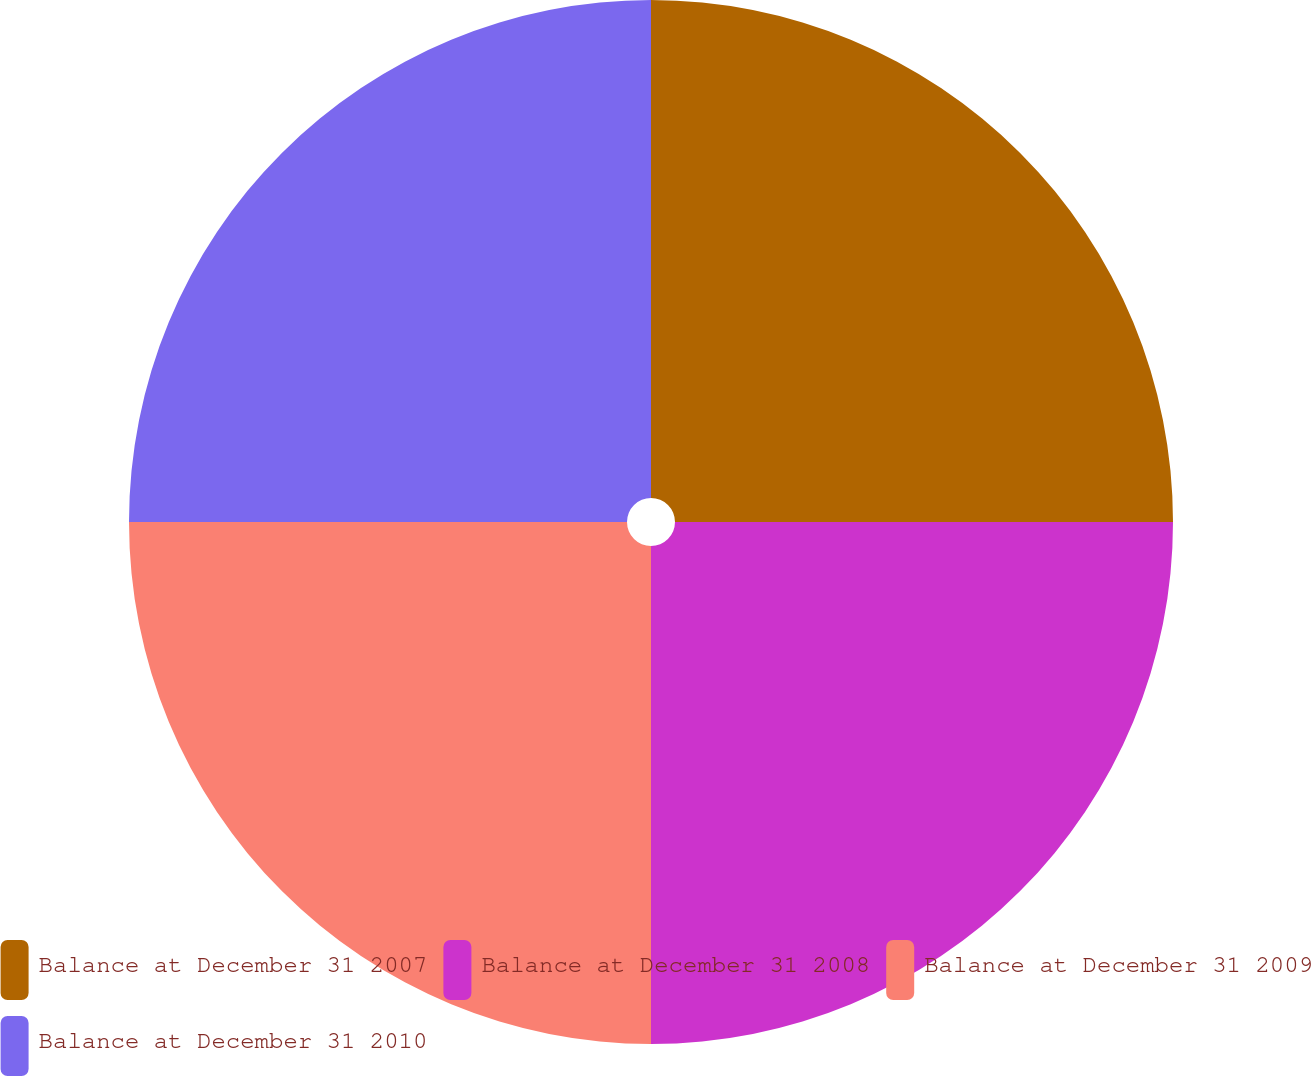Convert chart to OTSL. <chart><loc_0><loc_0><loc_500><loc_500><pie_chart><fcel>Balance at December 31 2007<fcel>Balance at December 31 2008<fcel>Balance at December 31 2009<fcel>Balance at December 31 2010<nl><fcel>25.0%<fcel>25.0%<fcel>25.0%<fcel>25.0%<nl></chart> 